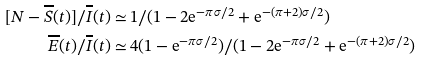<formula> <loc_0><loc_0><loc_500><loc_500>[ N - \overline { S } ( t ) ] / \overline { I } ( t ) \simeq & \, 1 / ( 1 - 2 \text {e} ^ { - \pi \sigma / 2 } + \text {e} ^ { - ( \pi + 2 ) \sigma / 2 } ) \\ \overline { E } ( t ) / \overline { I } ( t ) \simeq & \, 4 ( 1 - \text {e} ^ { - \pi \sigma / 2 } ) / ( 1 - 2 \text {e} ^ { - \pi \sigma / 2 } + \text {e} ^ { - ( \pi + 2 ) \sigma / 2 } )</formula> 